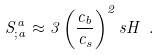Convert formula to latex. <formula><loc_0><loc_0><loc_500><loc_500>S ^ { a } _ { ; a } \approx 3 \left ( \frac { c _ { b } } { c _ { s } } \right ) ^ { 2 } s H \ .</formula> 